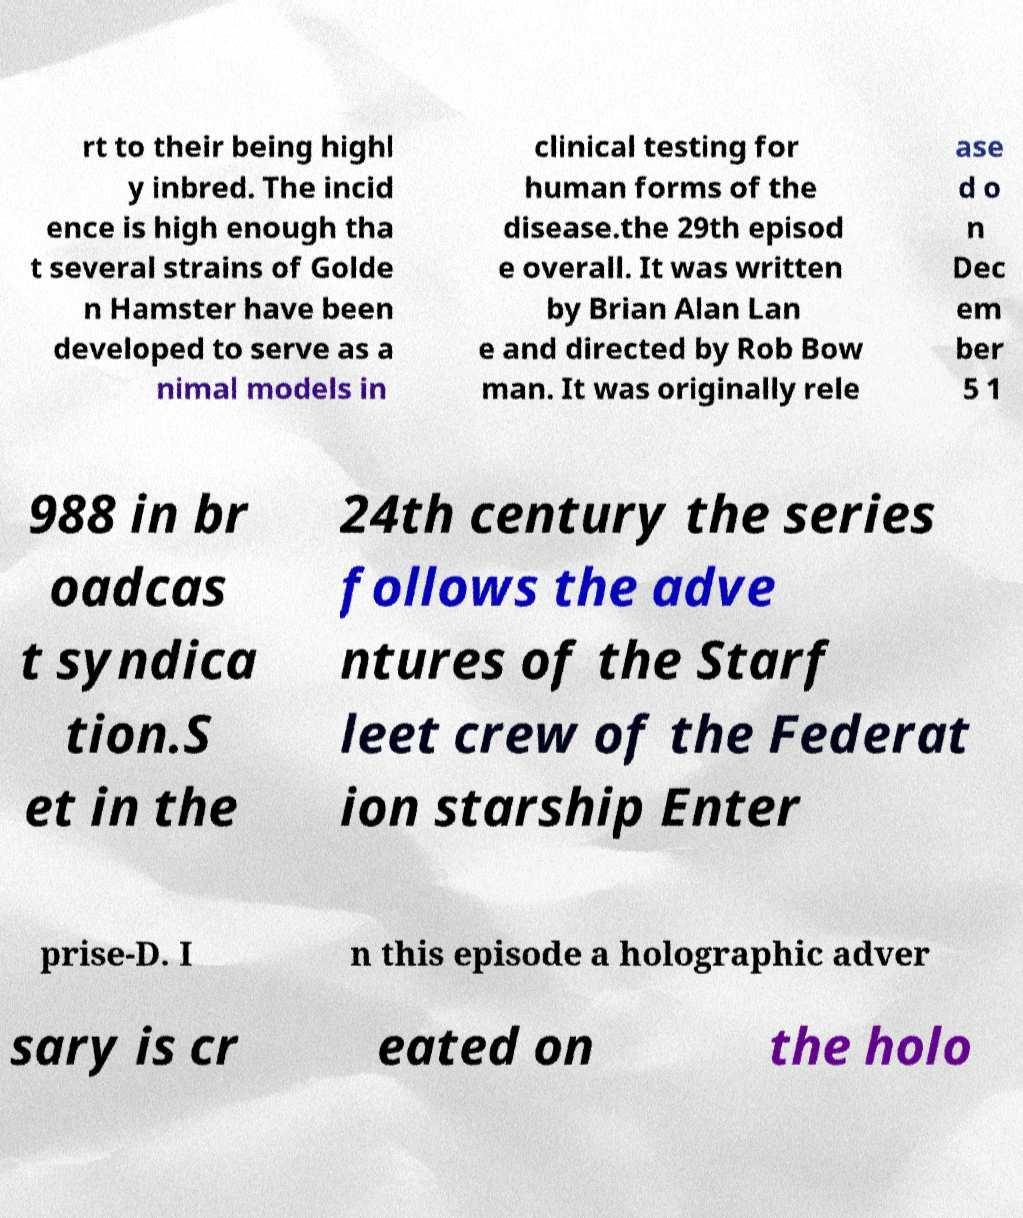Please identify and transcribe the text found in this image. rt to their being highl y inbred. The incid ence is high enough tha t several strains of Golde n Hamster have been developed to serve as a nimal models in clinical testing for human forms of the disease.the 29th episod e overall. It was written by Brian Alan Lan e and directed by Rob Bow man. It was originally rele ase d o n Dec em ber 5 1 988 in br oadcas t syndica tion.S et in the 24th century the series follows the adve ntures of the Starf leet crew of the Federat ion starship Enter prise-D. I n this episode a holographic adver sary is cr eated on the holo 